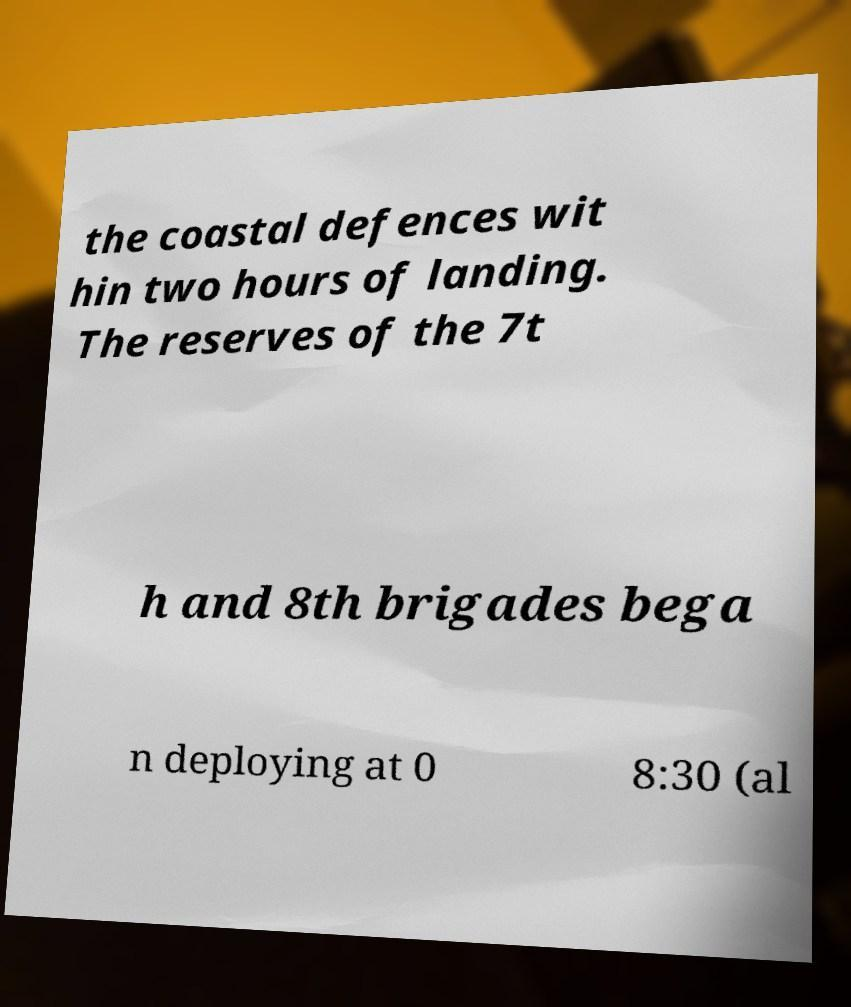Can you accurately transcribe the text from the provided image for me? the coastal defences wit hin two hours of landing. The reserves of the 7t h and 8th brigades bega n deploying at 0 8:30 (al 